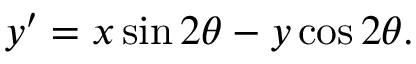Convert formula to latex. <formula><loc_0><loc_0><loc_500><loc_500>y ^ { \prime } = x \sin 2 \theta - y \cos 2 \theta .</formula> 